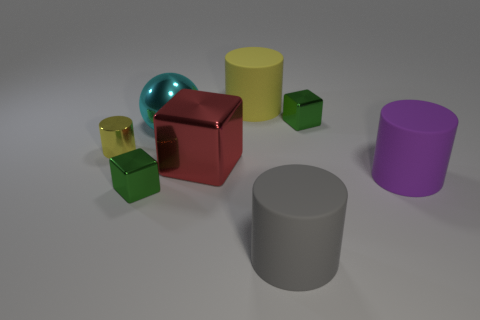Is there a small metal thing that has the same color as the big metal sphere?
Offer a very short reply. No. Do the red metallic object and the small green thing on the left side of the big yellow matte thing have the same shape?
Provide a short and direct response. Yes. Is there a gray cylinder made of the same material as the cyan object?
Give a very brief answer. No. Is there a shiny cube in front of the green shiny block left of the big red cube right of the large cyan metallic thing?
Provide a succinct answer. No. What number of other objects are the same shape as the small yellow object?
Your answer should be very brief. 3. There is a large shiny object in front of the big cyan object to the right of the tiny object in front of the tiny cylinder; what color is it?
Keep it short and to the point. Red. What number of red cubes are there?
Your answer should be compact. 1. How many big objects are brown things or spheres?
Give a very brief answer. 1. There is a purple object that is the same size as the sphere; what shape is it?
Keep it short and to the point. Cylinder. Is there any other thing that has the same size as the purple cylinder?
Give a very brief answer. Yes. 